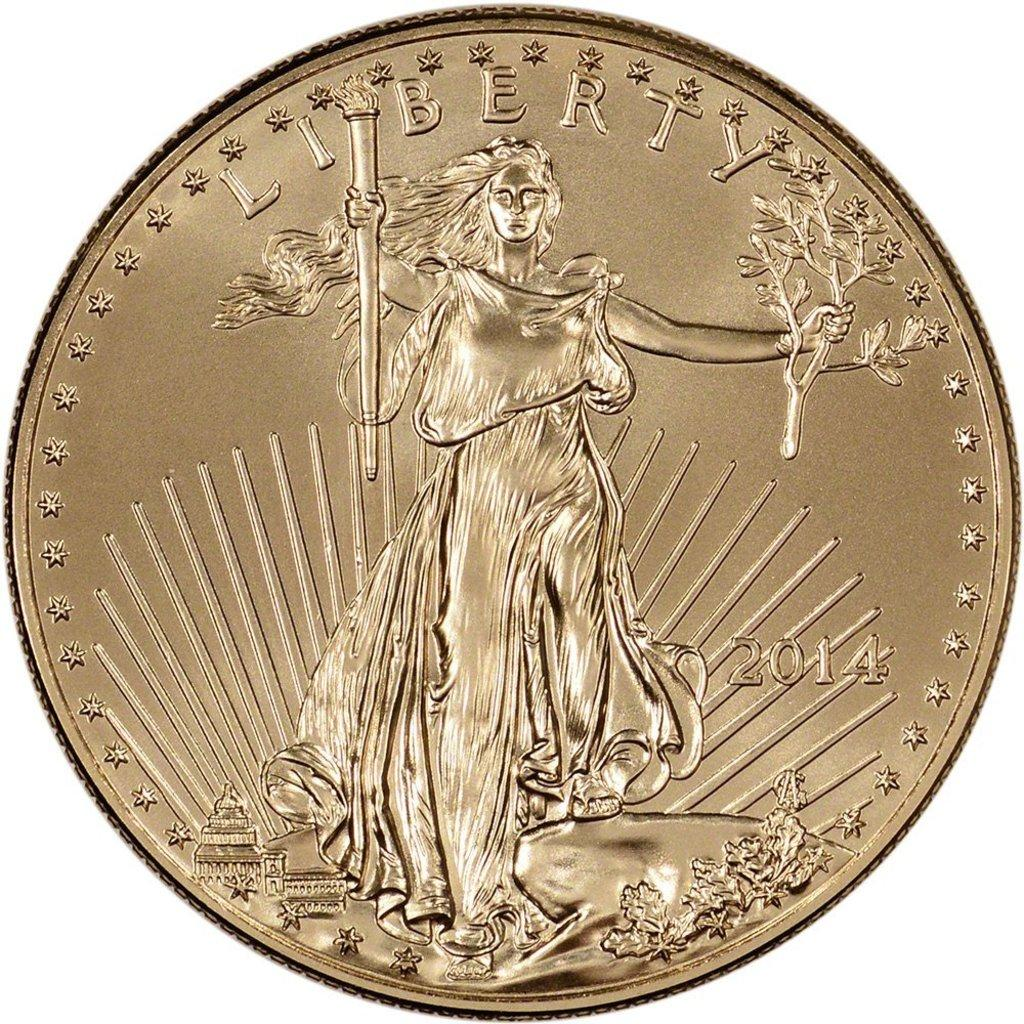What object is the main subject of the image? There is a coin in the image. What is depicted on the coin? The coin has a sculpture of a person. Are there any words or letters on the coin? Yes, there are letters on the coin. What is the color of the background in the image? The background of the image appears to be white. How many ducks are swimming in the water in the image? There are no ducks or water present in the image; it features a coin with a sculpture and letters. Are there any kittens playing with the letters on the coin? There are no kittens present in the image; it only features a coin with a sculpture and letters. 